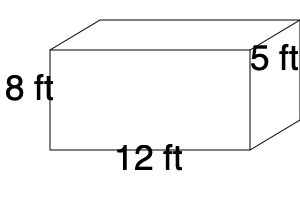Your child's virtual learning space needs to be reorganized. You have a rectangular storage container with the dimensions shown in the diagram. Calculate the volume of this container in cubic feet. How many 1-foot cube boxes could fit inside this container? To calculate the volume of a rectangular prism, we use the formula:

$$ V = l \times w \times h $$

Where:
$V$ = volume
$l$ = length
$w$ = width
$h$ = height

Given the dimensions in the diagram:
Length ($l$) = 12 ft
Width ($w$) = 5 ft
Height ($h$) = 8 ft

Let's substitute these values into the formula:

$$ V = 12 \text{ ft} \times 5 \text{ ft} \times 8 \text{ ft} $$
$$ V = 480 \text{ cubic feet} $$

Since each 1-foot cube box has a volume of 1 cubic foot, the number of such boxes that could fit inside this container is equal to the volume of the container in cubic feet.

Therefore, 480 1-foot cube boxes could fit inside this container.
Answer: 480 cubic feet; 480 boxes 